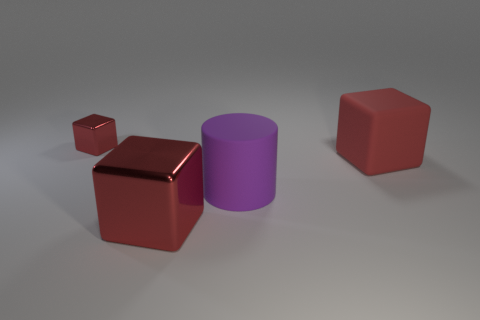There is a purple cylinder that is the same size as the red rubber object; what is its material?
Your answer should be compact. Rubber. The red object in front of the cube that is on the right side of the red shiny thing that is in front of the tiny red metallic object is made of what material?
Ensure brevity in your answer.  Metal. What is the color of the large matte block?
Your answer should be compact. Red. How many big things are either matte cylinders or matte things?
Ensure brevity in your answer.  2. There is another large cube that is the same color as the big matte block; what is it made of?
Give a very brief answer. Metal. Are the red object on the right side of the big red metal thing and the red object left of the large shiny object made of the same material?
Give a very brief answer. No. Is there a tiny purple sphere?
Your answer should be compact. No. Are there more tiny metal objects to the right of the large red matte cube than tiny red blocks that are on the right side of the matte cylinder?
Make the answer very short. No. There is a small thing that is the same shape as the large metallic object; what is its material?
Provide a succinct answer. Metal. Is there anything else that is the same size as the purple rubber cylinder?
Provide a succinct answer. Yes. 